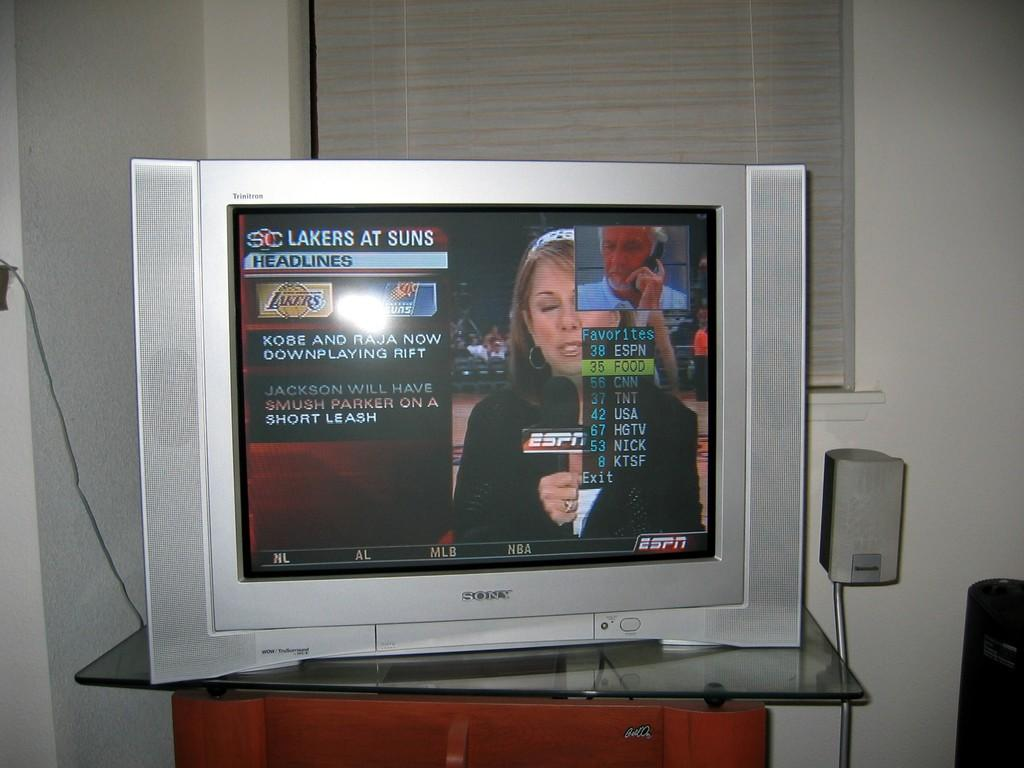<image>
Give a short and clear explanation of the subsequent image. A television with the words Lakers at Suns on the top left of the screen. 